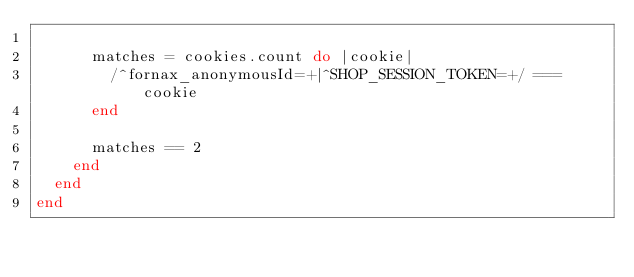<code> <loc_0><loc_0><loc_500><loc_500><_Ruby_>
      matches = cookies.count do |cookie|
        /^fornax_anonymousId=+|^SHOP_SESSION_TOKEN=+/ === cookie
      end

      matches == 2
    end
  end
end
</code> 